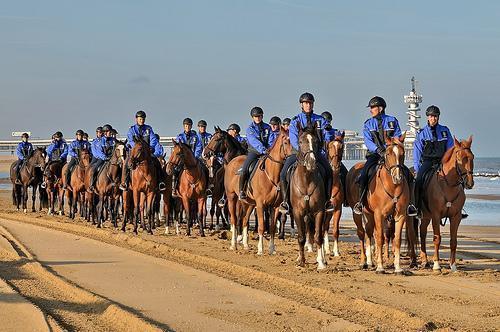How many horses are there?
Give a very brief answer. 5. How many laptop computers are in this image?
Give a very brief answer. 0. 